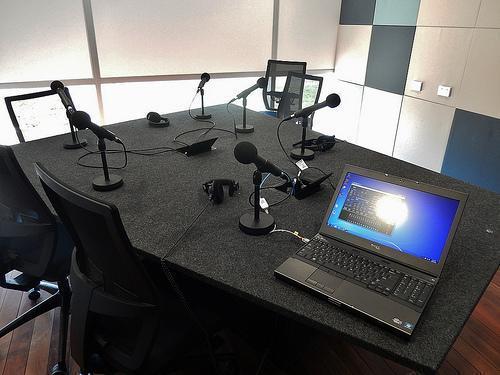How many laptops on the table?
Give a very brief answer. 1. 